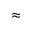<formula> <loc_0><loc_0><loc_500><loc_500>\approx</formula> 